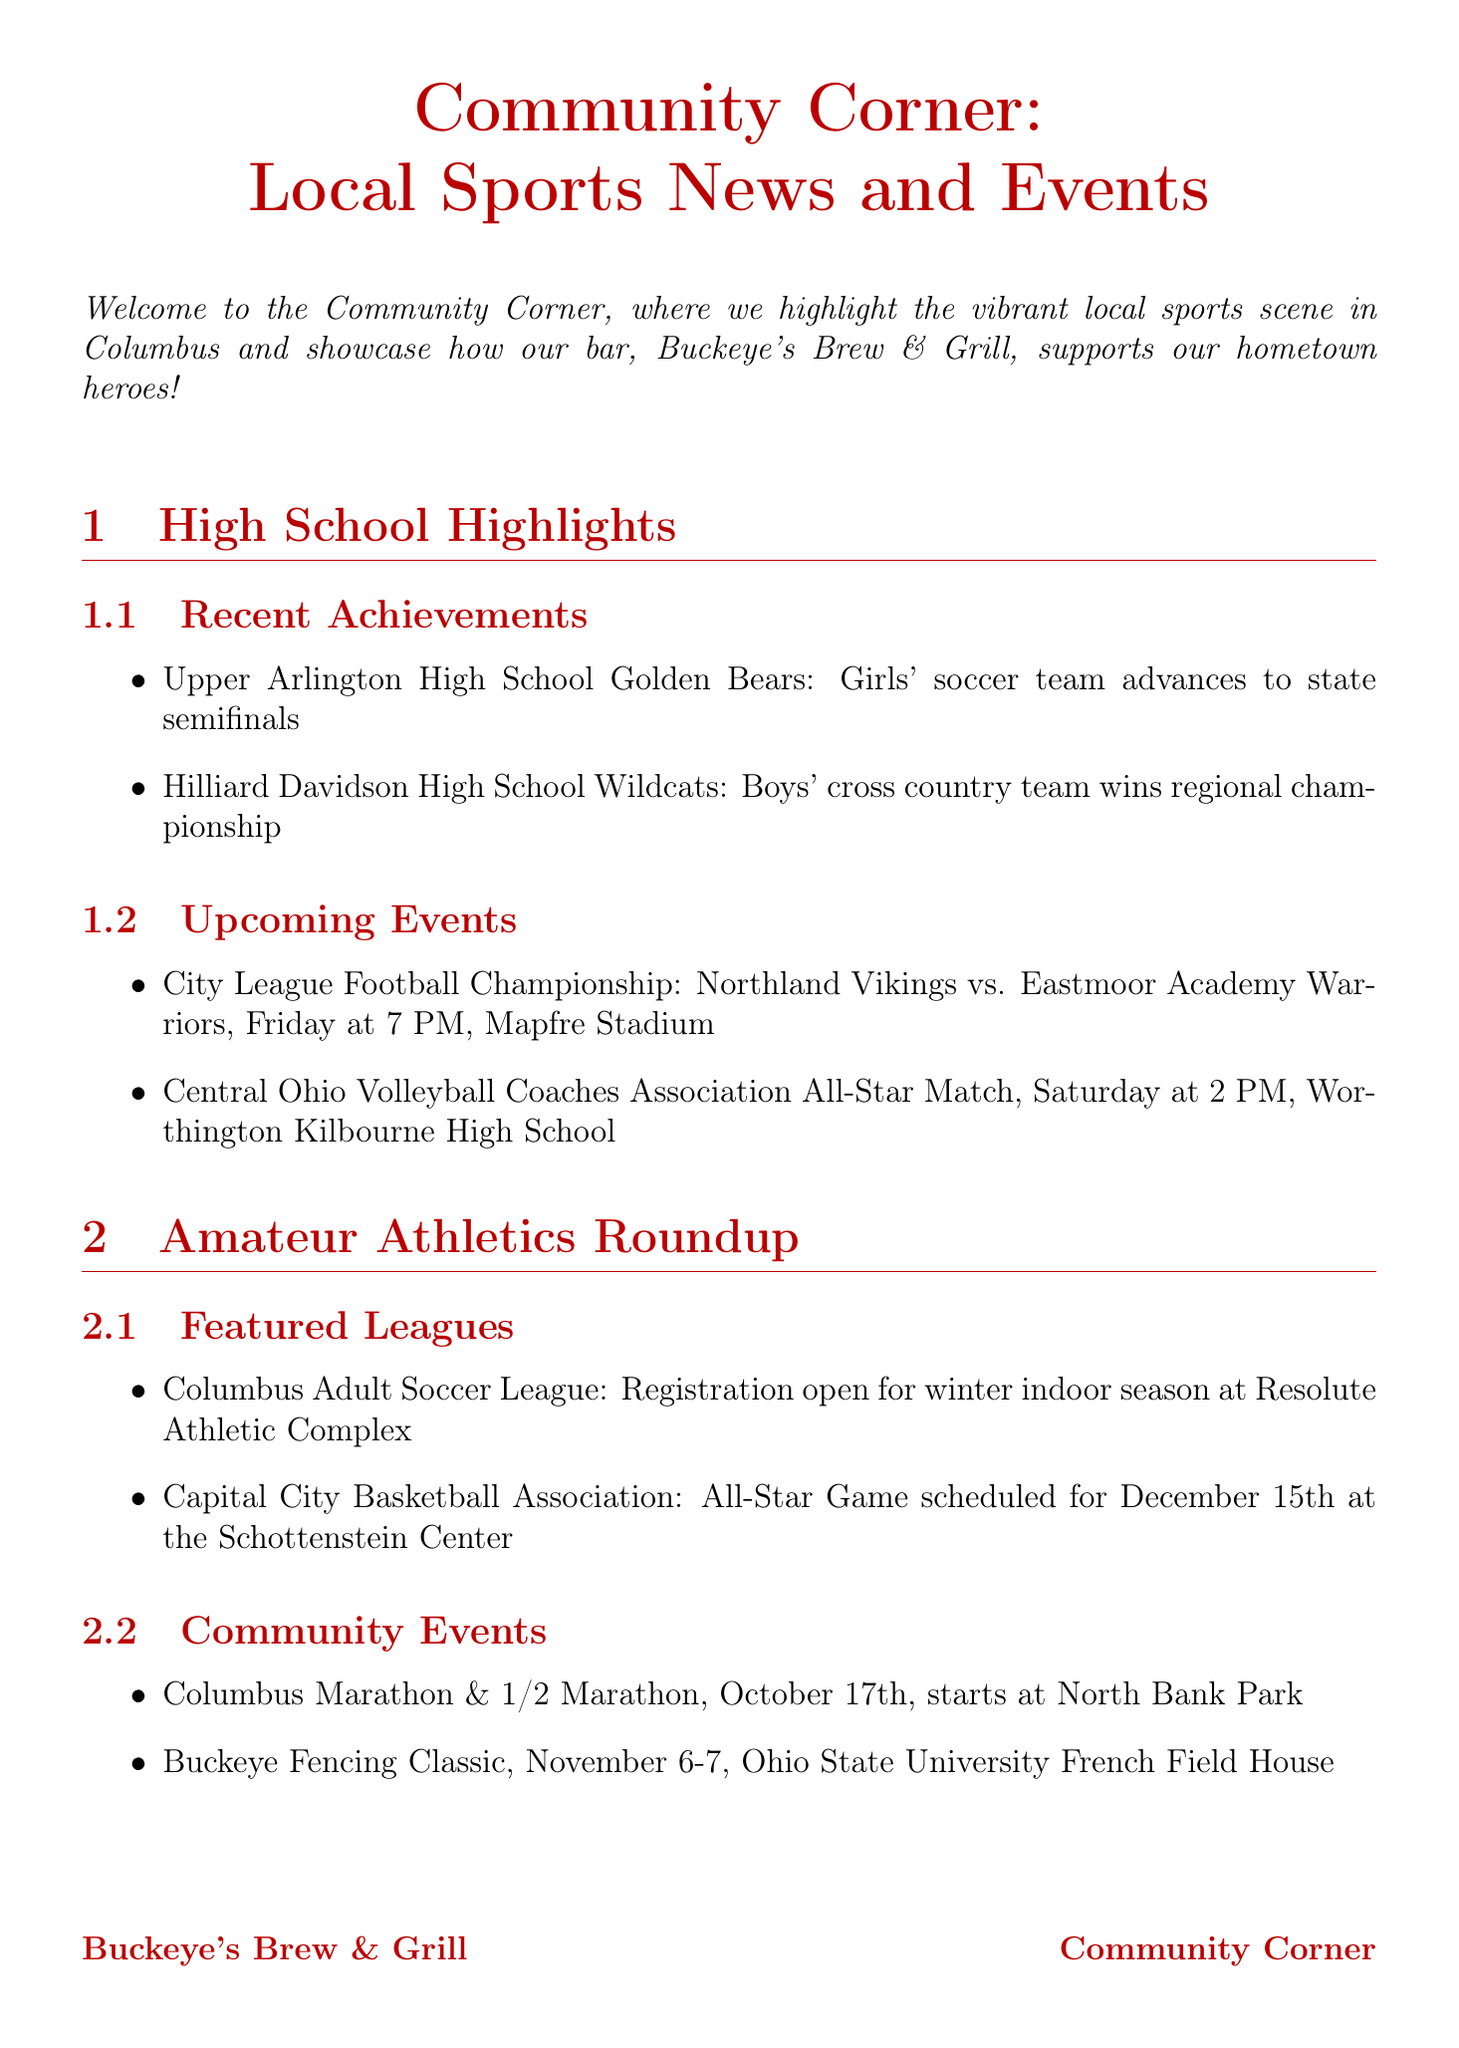What is the title of the newsletter? The title of the newsletter is found at the beginning of the document.
Answer: Community Corner: Local Sports News and Events Which team advanced to the state semifinals? This information is found in the high school spotlight section.
Answer: Girls' soccer team What is scheduled for December 15th? The document mentions a specific amateur sports event on that date.
Answer: All-Star Game When is the City League Football Championship? The date of the championship is mentioned in the upcoming events section.
Answer: Friday at 7 PM What discount is offered on Team Tuesday? This relates to the ongoing programs supporting local teams detailed in the document.
Answer: 10% of Tuesday sales Who can people meet at the upcoming event on Wednesday? This question pertains to a specific event listed in the upcoming events section.
Answer: Local high school football coaches What is the special offer during Meet the Coaches Night? This information can be found in the details of the event mentioned in the document.
Answer: Free appetizer with any entrée purchase What is the name of the current donation drive? This information is included in the donation drives section of the document.
Answer: Gear Up for Winter What type of food is featured for the Amateur Athlete Appreciation Weekend? The document provides a detail about a specific item during a community event.
Answer: Power Play Platter 